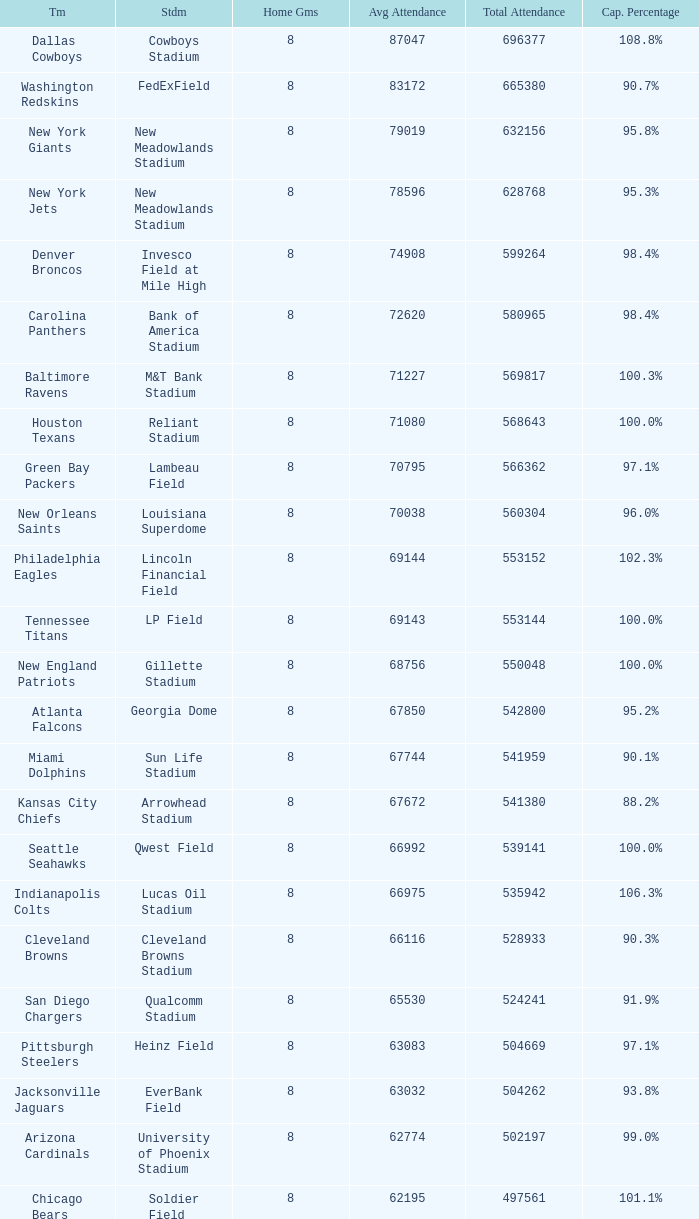What was the capacity for the Denver Broncos? 98.4%. 